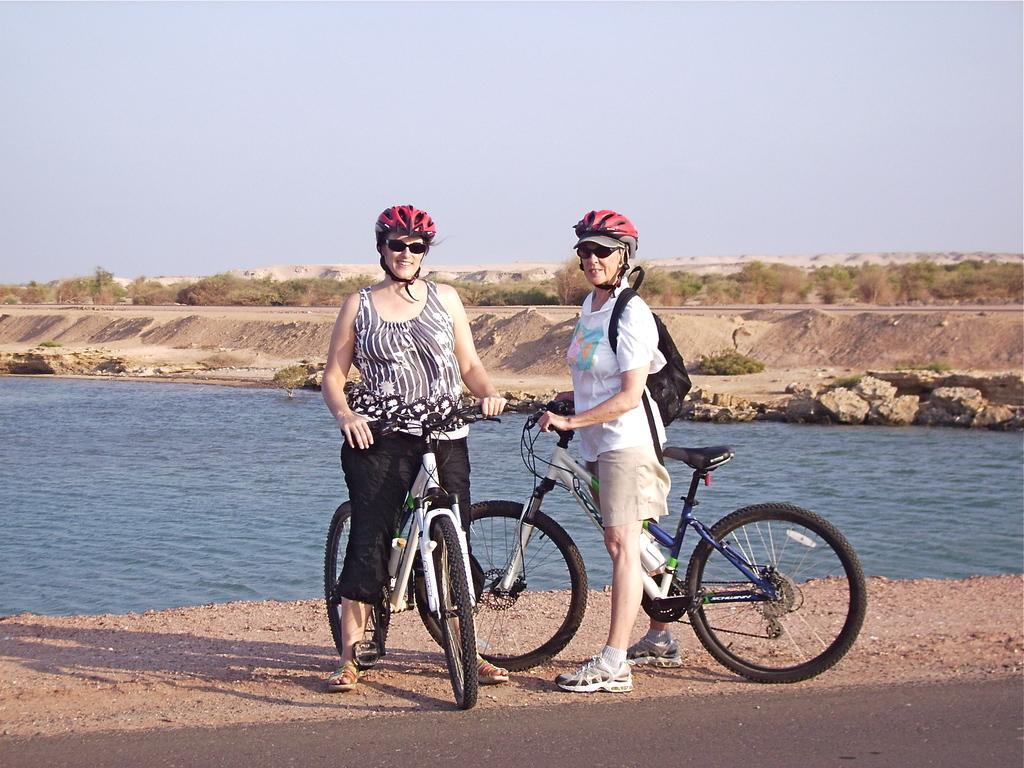How would you summarize this image in a sentence or two? In this picture we can see there are two people are standing with their bicycles on the path and behind the people there is water, sand, trees and sky. 